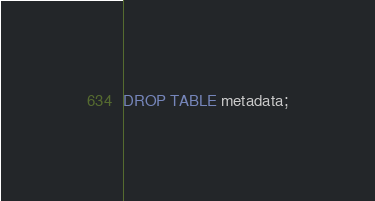<code> <loc_0><loc_0><loc_500><loc_500><_SQL_>DROP TABLE metadata;</code> 